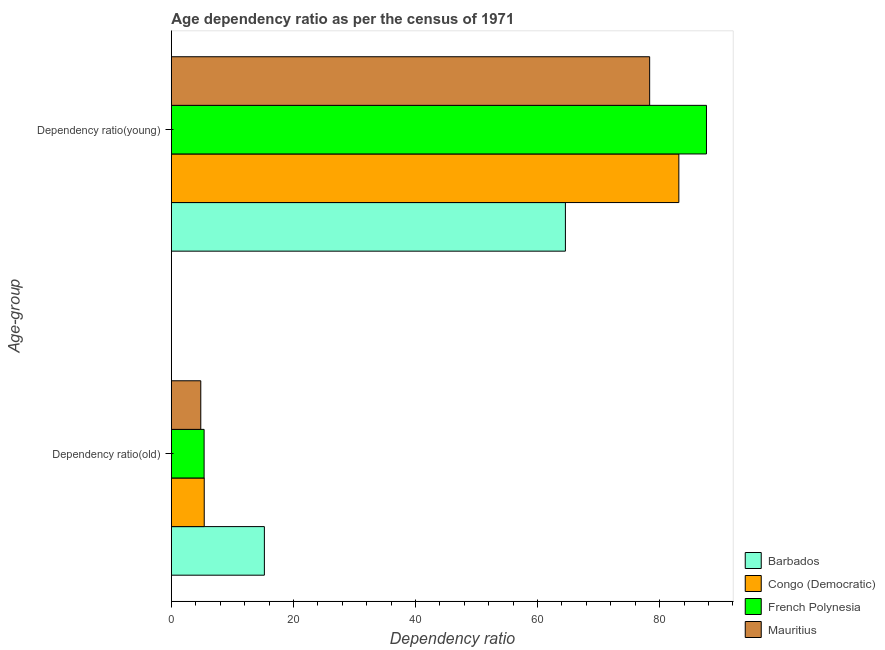Are the number of bars per tick equal to the number of legend labels?
Keep it short and to the point. Yes. How many bars are there on the 1st tick from the top?
Your answer should be compact. 4. How many bars are there on the 1st tick from the bottom?
Offer a terse response. 4. What is the label of the 2nd group of bars from the top?
Your answer should be very brief. Dependency ratio(old). What is the age dependency ratio(old) in French Polynesia?
Your response must be concise. 5.36. Across all countries, what is the maximum age dependency ratio(old)?
Offer a very short reply. 15.24. Across all countries, what is the minimum age dependency ratio(old)?
Give a very brief answer. 4.82. In which country was the age dependency ratio(old) maximum?
Offer a very short reply. Barbados. In which country was the age dependency ratio(old) minimum?
Make the answer very short. Mauritius. What is the total age dependency ratio(old) in the graph?
Make the answer very short. 30.8. What is the difference between the age dependency ratio(old) in Mauritius and that in Congo (Democratic)?
Provide a succinct answer. -0.56. What is the difference between the age dependency ratio(old) in Mauritius and the age dependency ratio(young) in Barbados?
Your answer should be compact. -59.75. What is the average age dependency ratio(old) per country?
Give a very brief answer. 7.7. What is the difference between the age dependency ratio(young) and age dependency ratio(old) in Barbados?
Your response must be concise. 49.33. What is the ratio of the age dependency ratio(young) in French Polynesia to that in Barbados?
Your response must be concise. 1.36. Is the age dependency ratio(young) in French Polynesia less than that in Congo (Democratic)?
Give a very brief answer. No. What does the 4th bar from the top in Dependency ratio(young) represents?
Provide a succinct answer. Barbados. What does the 2nd bar from the bottom in Dependency ratio(young) represents?
Provide a short and direct response. Congo (Democratic). How many bars are there?
Your answer should be very brief. 8. What is the difference between two consecutive major ticks on the X-axis?
Provide a succinct answer. 20. Does the graph contain any zero values?
Ensure brevity in your answer.  No. Where does the legend appear in the graph?
Keep it short and to the point. Bottom right. How many legend labels are there?
Give a very brief answer. 4. How are the legend labels stacked?
Offer a very short reply. Vertical. What is the title of the graph?
Offer a terse response. Age dependency ratio as per the census of 1971. Does "Chad" appear as one of the legend labels in the graph?
Offer a terse response. No. What is the label or title of the X-axis?
Your answer should be very brief. Dependency ratio. What is the label or title of the Y-axis?
Give a very brief answer. Age-group. What is the Dependency ratio in Barbados in Dependency ratio(old)?
Offer a terse response. 15.24. What is the Dependency ratio of Congo (Democratic) in Dependency ratio(old)?
Provide a short and direct response. 5.38. What is the Dependency ratio of French Polynesia in Dependency ratio(old)?
Your response must be concise. 5.36. What is the Dependency ratio of Mauritius in Dependency ratio(old)?
Make the answer very short. 4.82. What is the Dependency ratio in Barbados in Dependency ratio(young)?
Offer a very short reply. 64.57. What is the Dependency ratio of Congo (Democratic) in Dependency ratio(young)?
Your response must be concise. 83.16. What is the Dependency ratio in French Polynesia in Dependency ratio(young)?
Your response must be concise. 87.68. What is the Dependency ratio in Mauritius in Dependency ratio(young)?
Provide a succinct answer. 78.37. Across all Age-group, what is the maximum Dependency ratio of Barbados?
Your response must be concise. 64.57. Across all Age-group, what is the maximum Dependency ratio in Congo (Democratic)?
Provide a succinct answer. 83.16. Across all Age-group, what is the maximum Dependency ratio in French Polynesia?
Your answer should be very brief. 87.68. Across all Age-group, what is the maximum Dependency ratio in Mauritius?
Your answer should be very brief. 78.37. Across all Age-group, what is the minimum Dependency ratio in Barbados?
Ensure brevity in your answer.  15.24. Across all Age-group, what is the minimum Dependency ratio of Congo (Democratic)?
Make the answer very short. 5.38. Across all Age-group, what is the minimum Dependency ratio in French Polynesia?
Ensure brevity in your answer.  5.36. Across all Age-group, what is the minimum Dependency ratio of Mauritius?
Offer a very short reply. 4.82. What is the total Dependency ratio in Barbados in the graph?
Your response must be concise. 79.81. What is the total Dependency ratio in Congo (Democratic) in the graph?
Your answer should be compact. 88.54. What is the total Dependency ratio in French Polynesia in the graph?
Offer a very short reply. 93.05. What is the total Dependency ratio of Mauritius in the graph?
Your answer should be compact. 83.19. What is the difference between the Dependency ratio of Barbados in Dependency ratio(old) and that in Dependency ratio(young)?
Your response must be concise. -49.33. What is the difference between the Dependency ratio in Congo (Democratic) in Dependency ratio(old) and that in Dependency ratio(young)?
Provide a short and direct response. -77.77. What is the difference between the Dependency ratio of French Polynesia in Dependency ratio(old) and that in Dependency ratio(young)?
Give a very brief answer. -82.32. What is the difference between the Dependency ratio in Mauritius in Dependency ratio(old) and that in Dependency ratio(young)?
Provide a short and direct response. -73.56. What is the difference between the Dependency ratio of Barbados in Dependency ratio(old) and the Dependency ratio of Congo (Democratic) in Dependency ratio(young)?
Keep it short and to the point. -67.92. What is the difference between the Dependency ratio in Barbados in Dependency ratio(old) and the Dependency ratio in French Polynesia in Dependency ratio(young)?
Your answer should be compact. -72.45. What is the difference between the Dependency ratio of Barbados in Dependency ratio(old) and the Dependency ratio of Mauritius in Dependency ratio(young)?
Make the answer very short. -63.14. What is the difference between the Dependency ratio in Congo (Democratic) in Dependency ratio(old) and the Dependency ratio in French Polynesia in Dependency ratio(young)?
Your response must be concise. -82.3. What is the difference between the Dependency ratio in Congo (Democratic) in Dependency ratio(old) and the Dependency ratio in Mauritius in Dependency ratio(young)?
Offer a terse response. -72.99. What is the difference between the Dependency ratio in French Polynesia in Dependency ratio(old) and the Dependency ratio in Mauritius in Dependency ratio(young)?
Offer a very short reply. -73.01. What is the average Dependency ratio of Barbados per Age-group?
Your answer should be compact. 39.9. What is the average Dependency ratio of Congo (Democratic) per Age-group?
Offer a terse response. 44.27. What is the average Dependency ratio in French Polynesia per Age-group?
Provide a succinct answer. 46.52. What is the average Dependency ratio in Mauritius per Age-group?
Give a very brief answer. 41.6. What is the difference between the Dependency ratio in Barbados and Dependency ratio in Congo (Democratic) in Dependency ratio(old)?
Provide a succinct answer. 9.86. What is the difference between the Dependency ratio in Barbados and Dependency ratio in French Polynesia in Dependency ratio(old)?
Offer a very short reply. 9.87. What is the difference between the Dependency ratio of Barbados and Dependency ratio of Mauritius in Dependency ratio(old)?
Ensure brevity in your answer.  10.42. What is the difference between the Dependency ratio of Congo (Democratic) and Dependency ratio of French Polynesia in Dependency ratio(old)?
Provide a succinct answer. 0.02. What is the difference between the Dependency ratio in Congo (Democratic) and Dependency ratio in Mauritius in Dependency ratio(old)?
Your response must be concise. 0.56. What is the difference between the Dependency ratio of French Polynesia and Dependency ratio of Mauritius in Dependency ratio(old)?
Your answer should be compact. 0.55. What is the difference between the Dependency ratio of Barbados and Dependency ratio of Congo (Democratic) in Dependency ratio(young)?
Your response must be concise. -18.59. What is the difference between the Dependency ratio in Barbados and Dependency ratio in French Polynesia in Dependency ratio(young)?
Ensure brevity in your answer.  -23.12. What is the difference between the Dependency ratio in Barbados and Dependency ratio in Mauritius in Dependency ratio(young)?
Keep it short and to the point. -13.81. What is the difference between the Dependency ratio of Congo (Democratic) and Dependency ratio of French Polynesia in Dependency ratio(young)?
Ensure brevity in your answer.  -4.53. What is the difference between the Dependency ratio in Congo (Democratic) and Dependency ratio in Mauritius in Dependency ratio(young)?
Give a very brief answer. 4.78. What is the difference between the Dependency ratio in French Polynesia and Dependency ratio in Mauritius in Dependency ratio(young)?
Provide a short and direct response. 9.31. What is the ratio of the Dependency ratio in Barbados in Dependency ratio(old) to that in Dependency ratio(young)?
Offer a very short reply. 0.24. What is the ratio of the Dependency ratio of Congo (Democratic) in Dependency ratio(old) to that in Dependency ratio(young)?
Keep it short and to the point. 0.06. What is the ratio of the Dependency ratio of French Polynesia in Dependency ratio(old) to that in Dependency ratio(young)?
Offer a very short reply. 0.06. What is the ratio of the Dependency ratio of Mauritius in Dependency ratio(old) to that in Dependency ratio(young)?
Offer a terse response. 0.06. What is the difference between the highest and the second highest Dependency ratio in Barbados?
Provide a succinct answer. 49.33. What is the difference between the highest and the second highest Dependency ratio of Congo (Democratic)?
Keep it short and to the point. 77.77. What is the difference between the highest and the second highest Dependency ratio in French Polynesia?
Your answer should be compact. 82.32. What is the difference between the highest and the second highest Dependency ratio of Mauritius?
Your answer should be very brief. 73.56. What is the difference between the highest and the lowest Dependency ratio in Barbados?
Provide a succinct answer. 49.33. What is the difference between the highest and the lowest Dependency ratio in Congo (Democratic)?
Provide a short and direct response. 77.77. What is the difference between the highest and the lowest Dependency ratio of French Polynesia?
Provide a succinct answer. 82.32. What is the difference between the highest and the lowest Dependency ratio of Mauritius?
Give a very brief answer. 73.56. 